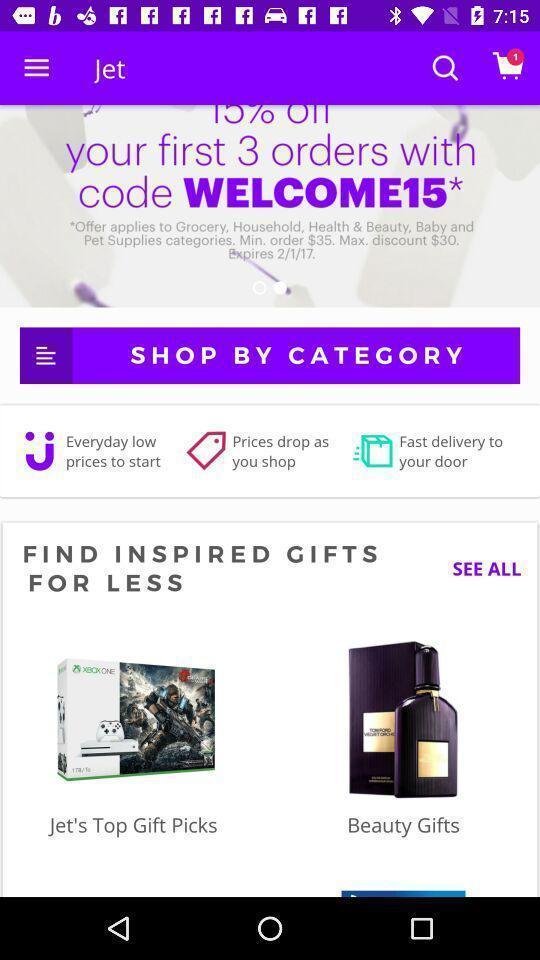Explain the elements present in this screenshot. Search page with different suggestions in the shopping app. 